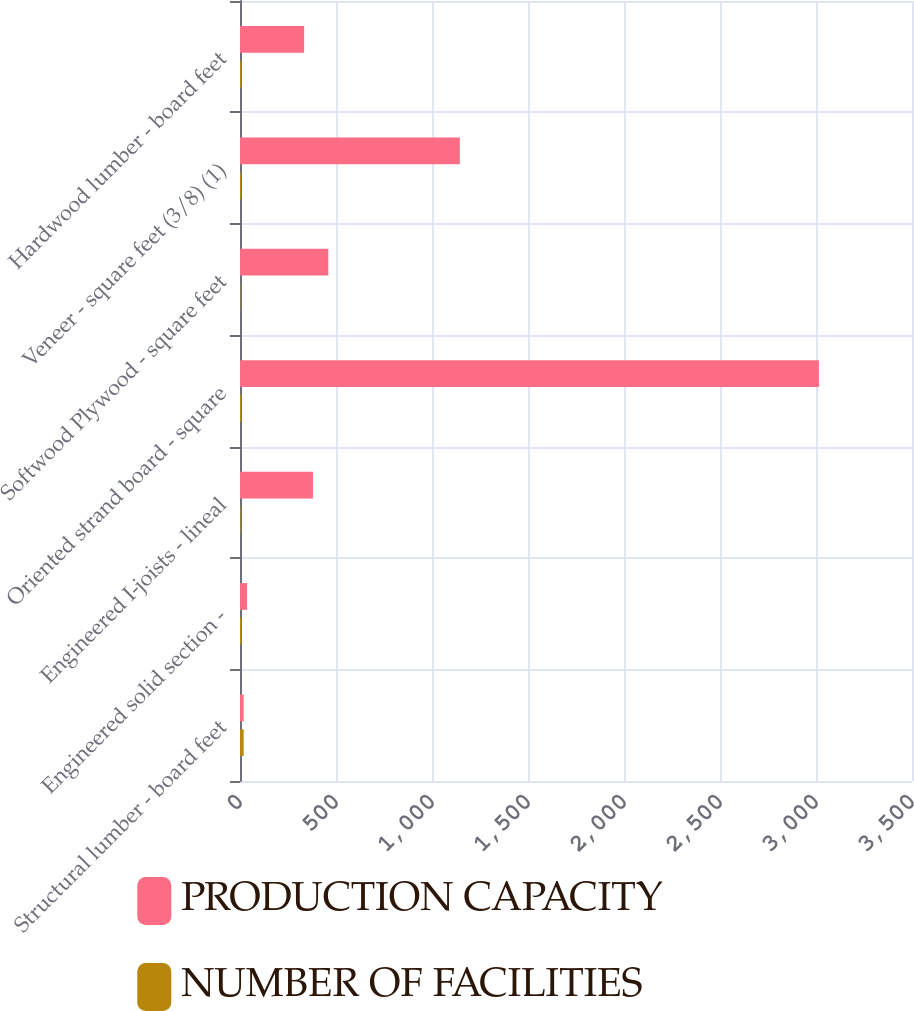Convert chart. <chart><loc_0><loc_0><loc_500><loc_500><stacked_bar_chart><ecel><fcel>Structural lumber - board feet<fcel>Engineered solid section -<fcel>Engineered I-joists - lineal<fcel>Oriented strand board - square<fcel>Softwood Plywood - square feet<fcel>Veneer - square feet (3/8) (1)<fcel>Hardwood lumber - board feet<nl><fcel>PRODUCTION CAPACITY<fcel>19<fcel>37<fcel>380<fcel>3015<fcel>460<fcel>1145<fcel>334<nl><fcel>NUMBER OF FACILITIES<fcel>19<fcel>8<fcel>3<fcel>6<fcel>2<fcel>5<fcel>7<nl></chart> 